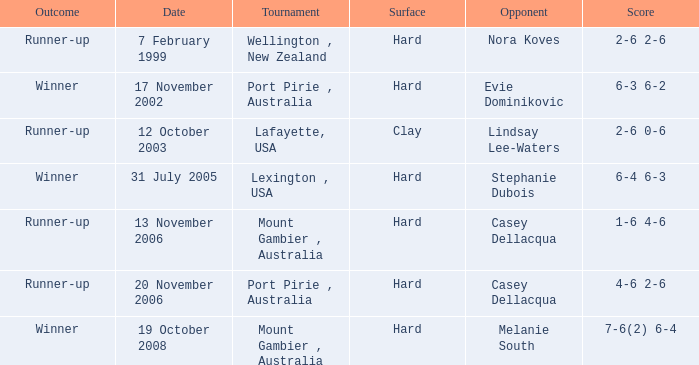When is an Opponent of evie dominikovic? 17 November 2002. 